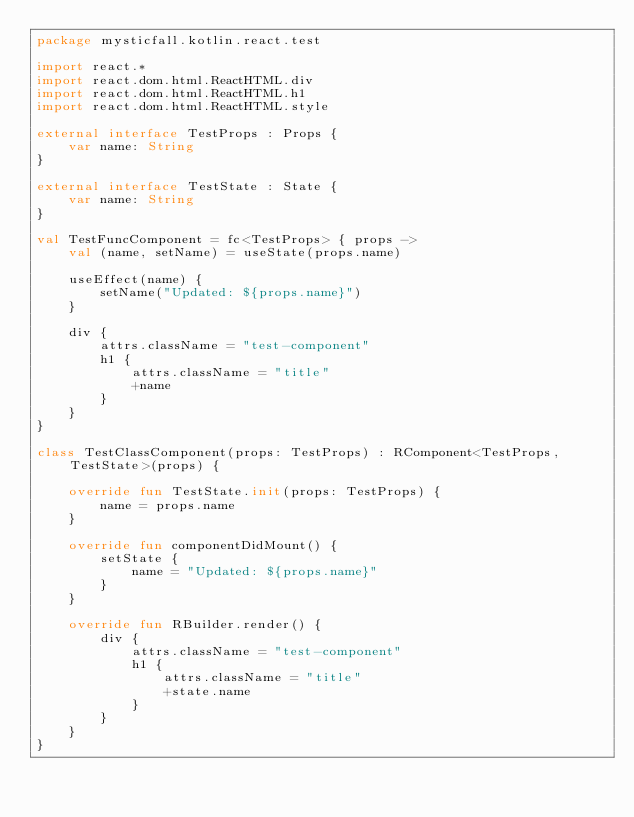<code> <loc_0><loc_0><loc_500><loc_500><_Kotlin_>package mysticfall.kotlin.react.test

import react.*
import react.dom.html.ReactHTML.div
import react.dom.html.ReactHTML.h1
import react.dom.html.ReactHTML.style

external interface TestProps : Props {
    var name: String
}

external interface TestState : State {
    var name: String
}

val TestFuncComponent = fc<TestProps> { props ->
    val (name, setName) = useState(props.name)

    useEffect(name) {
        setName("Updated: ${props.name}")
    }

    div {
        attrs.className = "test-component"
        h1 {
            attrs.className = "title"
            +name
        }
    }
}

class TestClassComponent(props: TestProps) : RComponent<TestProps, TestState>(props) {

    override fun TestState.init(props: TestProps) {
        name = props.name
    }

    override fun componentDidMount() {
        setState {
            name = "Updated: ${props.name}"
        }
    }

    override fun RBuilder.render() {
        div {
            attrs.className = "test-component"
            h1 {
                attrs.className = "title"
                +state.name
            }
        }
    }
}
</code> 